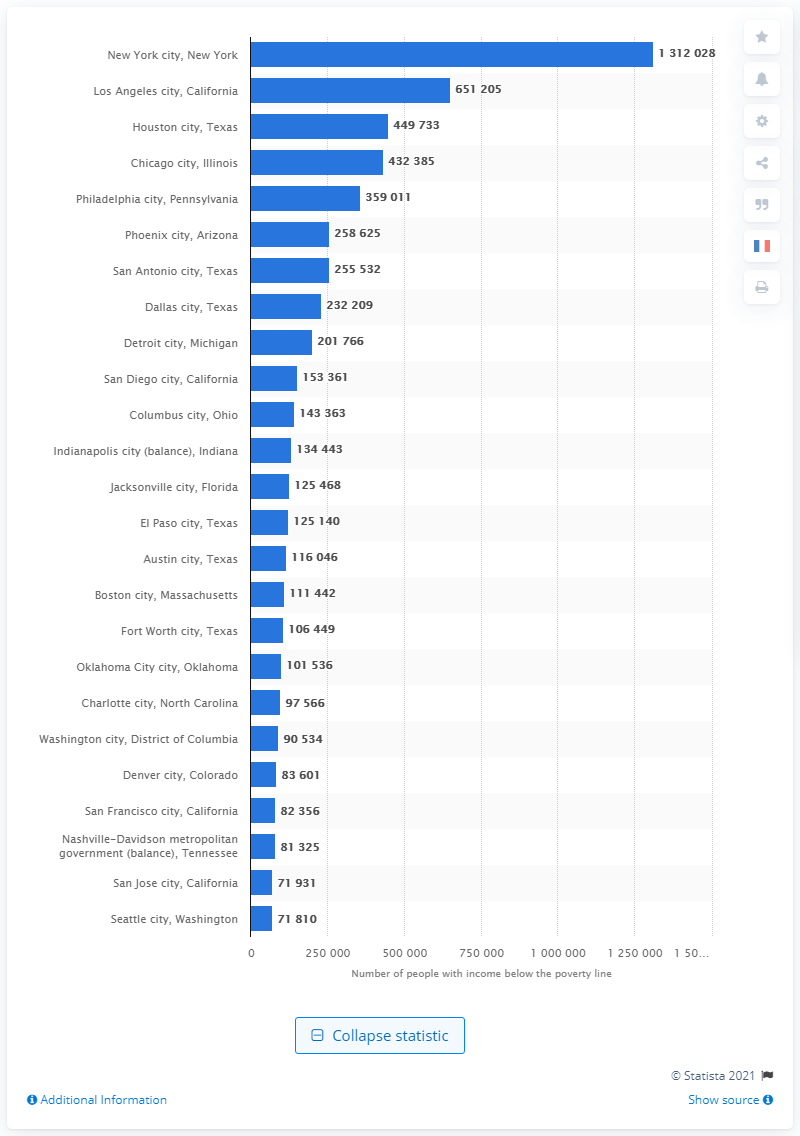Outline some significant characteristics in this image. In 2019, it is estimated that 131,2028 individuals in New York lived in poverty. 